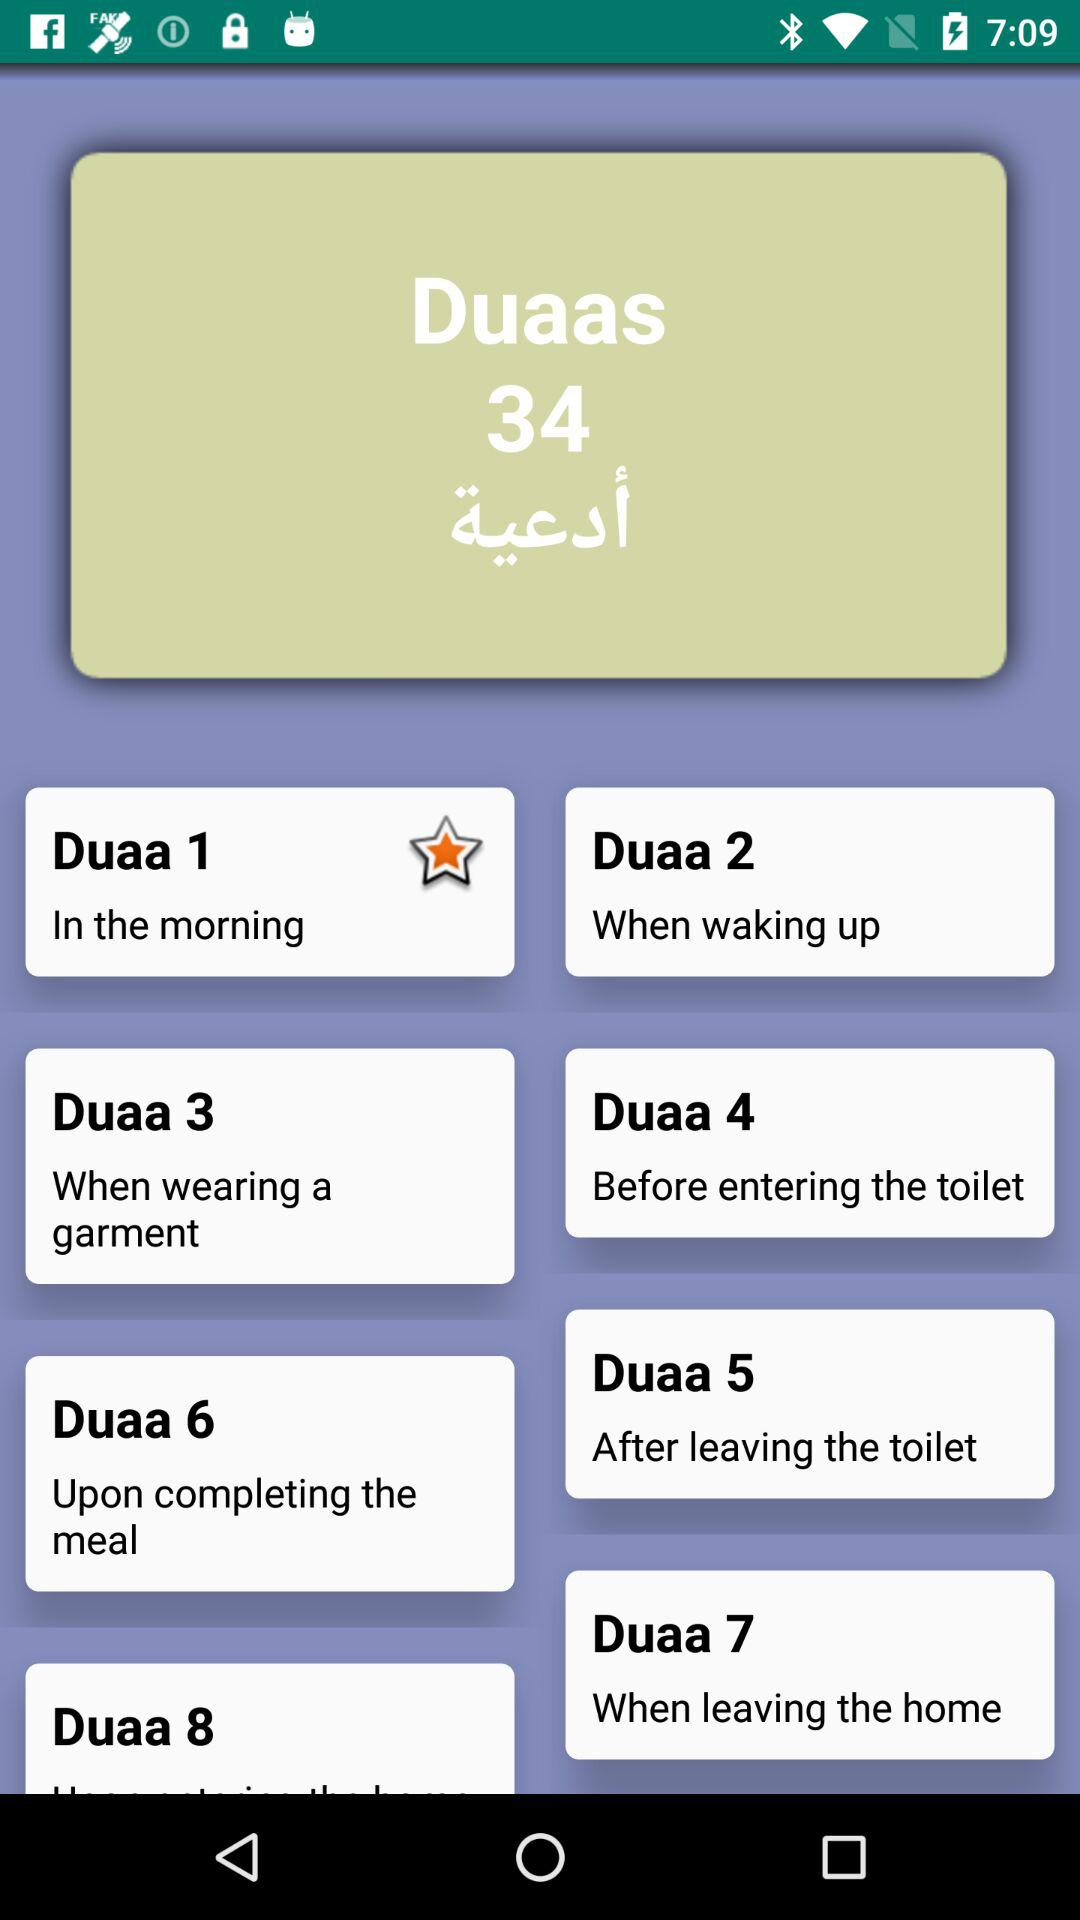What is the total number of Duaas? The total number of Duaas is 34. 